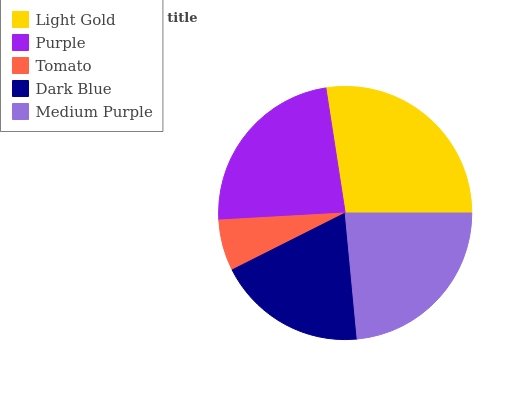Is Tomato the minimum?
Answer yes or no. Yes. Is Light Gold the maximum?
Answer yes or no. Yes. Is Purple the minimum?
Answer yes or no. No. Is Purple the maximum?
Answer yes or no. No. Is Light Gold greater than Purple?
Answer yes or no. Yes. Is Purple less than Light Gold?
Answer yes or no. Yes. Is Purple greater than Light Gold?
Answer yes or no. No. Is Light Gold less than Purple?
Answer yes or no. No. Is Purple the high median?
Answer yes or no. Yes. Is Purple the low median?
Answer yes or no. Yes. Is Light Gold the high median?
Answer yes or no. No. Is Dark Blue the low median?
Answer yes or no. No. 